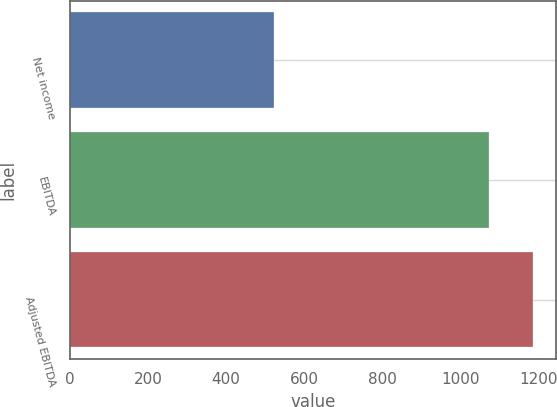<chart> <loc_0><loc_0><loc_500><loc_500><bar_chart><fcel>Net income<fcel>EBITDA<fcel>Adjusted EBITDA<nl><fcel>523<fcel>1071.7<fcel>1185.6<nl></chart> 